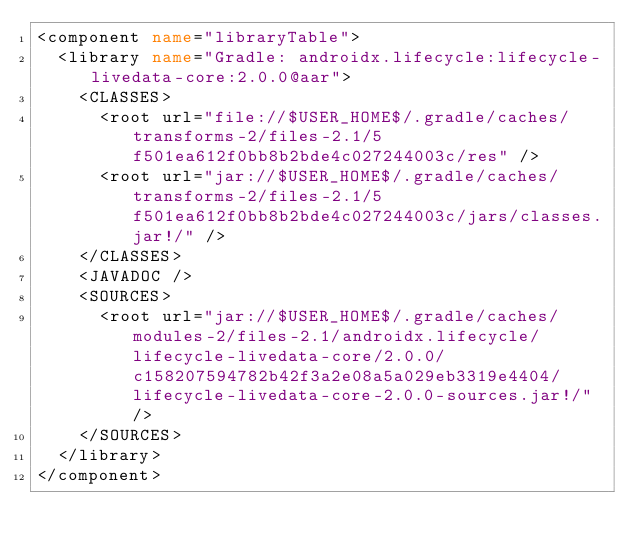Convert code to text. <code><loc_0><loc_0><loc_500><loc_500><_XML_><component name="libraryTable">
  <library name="Gradle: androidx.lifecycle:lifecycle-livedata-core:2.0.0@aar">
    <CLASSES>
      <root url="file://$USER_HOME$/.gradle/caches/transforms-2/files-2.1/5f501ea612f0bb8b2bde4c027244003c/res" />
      <root url="jar://$USER_HOME$/.gradle/caches/transforms-2/files-2.1/5f501ea612f0bb8b2bde4c027244003c/jars/classes.jar!/" />
    </CLASSES>
    <JAVADOC />
    <SOURCES>
      <root url="jar://$USER_HOME$/.gradle/caches/modules-2/files-2.1/androidx.lifecycle/lifecycle-livedata-core/2.0.0/c158207594782b42f3a2e08a5a029eb3319e4404/lifecycle-livedata-core-2.0.0-sources.jar!/" />
    </SOURCES>
  </library>
</component></code> 